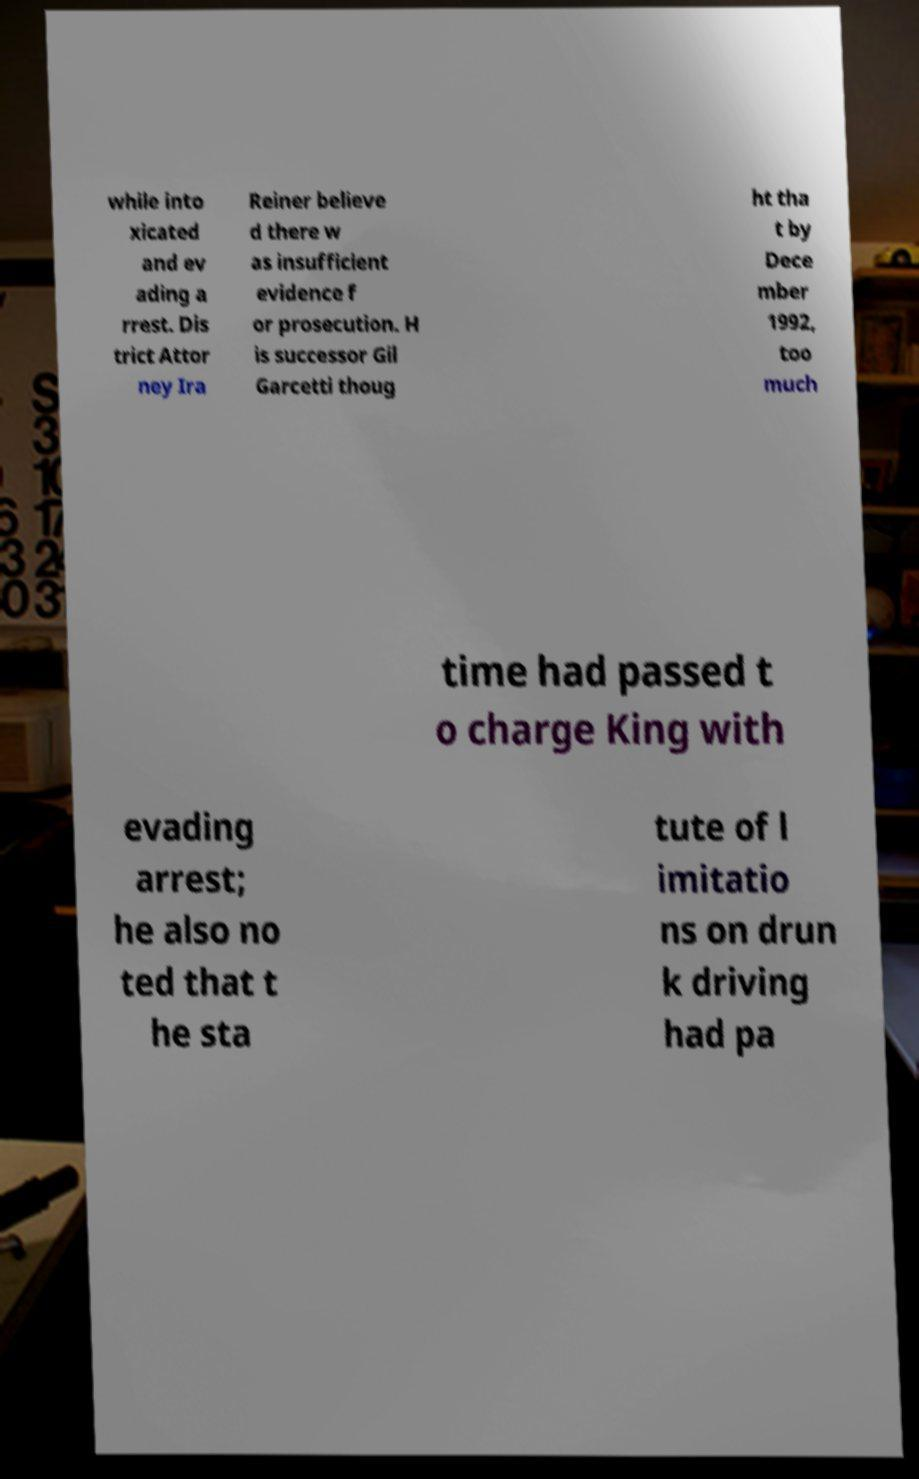Can you accurately transcribe the text from the provided image for me? while into xicated and ev ading a rrest. Dis trict Attor ney Ira Reiner believe d there w as insufficient evidence f or prosecution. H is successor Gil Garcetti thoug ht tha t by Dece mber 1992, too much time had passed t o charge King with evading arrest; he also no ted that t he sta tute of l imitatio ns on drun k driving had pa 